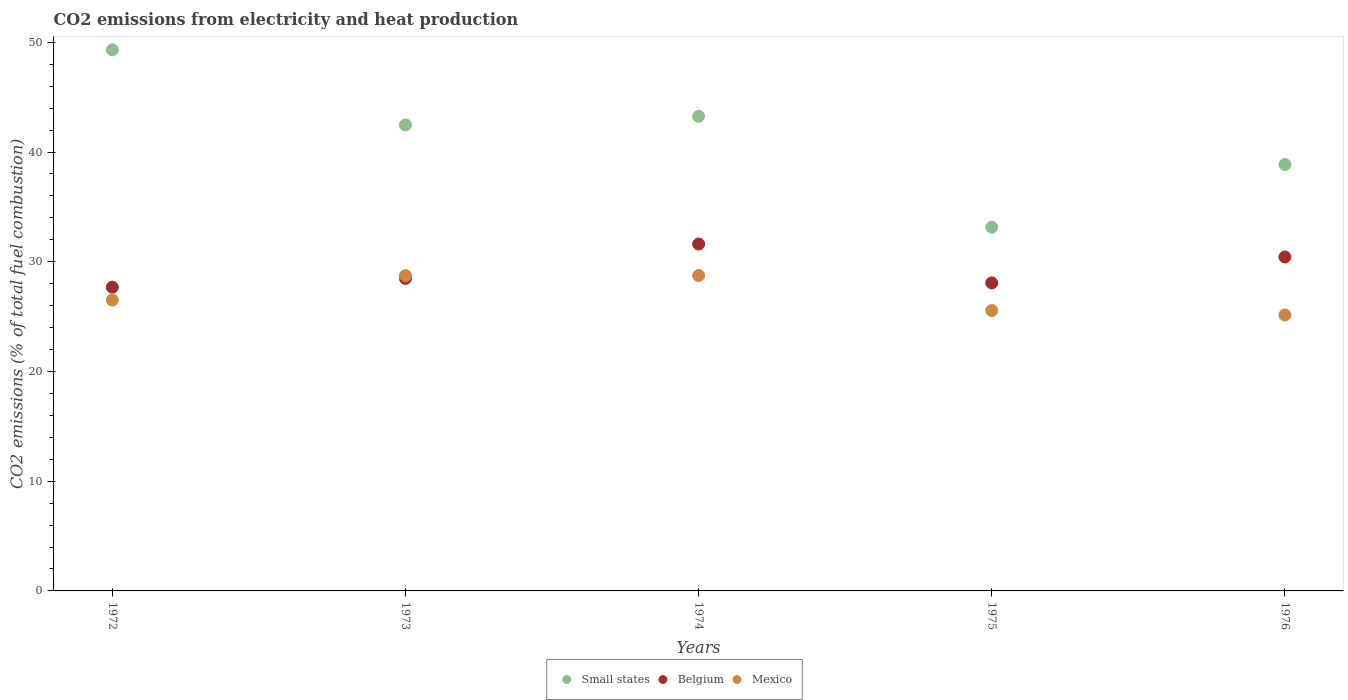What is the amount of CO2 emitted in Mexico in 1972?
Offer a very short reply. 26.51. Across all years, what is the maximum amount of CO2 emitted in Belgium?
Offer a very short reply. 31.62. Across all years, what is the minimum amount of CO2 emitted in Belgium?
Your answer should be compact. 27.68. In which year was the amount of CO2 emitted in Mexico maximum?
Your response must be concise. 1974. What is the total amount of CO2 emitted in Mexico in the graph?
Give a very brief answer. 134.69. What is the difference between the amount of CO2 emitted in Small states in 1972 and that in 1976?
Ensure brevity in your answer.  10.45. What is the difference between the amount of CO2 emitted in Belgium in 1975 and the amount of CO2 emitted in Mexico in 1972?
Provide a short and direct response. 1.56. What is the average amount of CO2 emitted in Belgium per year?
Your response must be concise. 29.26. In the year 1972, what is the difference between the amount of CO2 emitted in Belgium and amount of CO2 emitted in Mexico?
Offer a very short reply. 1.17. What is the ratio of the amount of CO2 emitted in Belgium in 1972 to that in 1975?
Your answer should be very brief. 0.99. What is the difference between the highest and the second highest amount of CO2 emitted in Belgium?
Keep it short and to the point. 1.18. What is the difference between the highest and the lowest amount of CO2 emitted in Mexico?
Offer a terse response. 3.6. Is it the case that in every year, the sum of the amount of CO2 emitted in Small states and amount of CO2 emitted in Belgium  is greater than the amount of CO2 emitted in Mexico?
Your answer should be very brief. Yes. Is the amount of CO2 emitted in Small states strictly greater than the amount of CO2 emitted in Belgium over the years?
Offer a very short reply. Yes. Is the amount of CO2 emitted in Small states strictly less than the amount of CO2 emitted in Mexico over the years?
Give a very brief answer. No. How many dotlines are there?
Make the answer very short. 3. How many years are there in the graph?
Give a very brief answer. 5. Are the values on the major ticks of Y-axis written in scientific E-notation?
Ensure brevity in your answer.  No. Where does the legend appear in the graph?
Give a very brief answer. Bottom center. How many legend labels are there?
Keep it short and to the point. 3. What is the title of the graph?
Offer a terse response. CO2 emissions from electricity and heat production. Does "Poland" appear as one of the legend labels in the graph?
Keep it short and to the point. No. What is the label or title of the Y-axis?
Your response must be concise. CO2 emissions (% of total fuel combustion). What is the CO2 emissions (% of total fuel combustion) in Small states in 1972?
Make the answer very short. 49.31. What is the CO2 emissions (% of total fuel combustion) of Belgium in 1972?
Give a very brief answer. 27.68. What is the CO2 emissions (% of total fuel combustion) in Mexico in 1972?
Provide a succinct answer. 26.51. What is the CO2 emissions (% of total fuel combustion) of Small states in 1973?
Make the answer very short. 42.47. What is the CO2 emissions (% of total fuel combustion) of Belgium in 1973?
Give a very brief answer. 28.48. What is the CO2 emissions (% of total fuel combustion) in Mexico in 1973?
Keep it short and to the point. 28.73. What is the CO2 emissions (% of total fuel combustion) of Small states in 1974?
Your answer should be very brief. 43.26. What is the CO2 emissions (% of total fuel combustion) in Belgium in 1974?
Provide a short and direct response. 31.62. What is the CO2 emissions (% of total fuel combustion) of Mexico in 1974?
Your answer should be very brief. 28.74. What is the CO2 emissions (% of total fuel combustion) in Small states in 1975?
Give a very brief answer. 33.15. What is the CO2 emissions (% of total fuel combustion) of Belgium in 1975?
Your answer should be very brief. 28.07. What is the CO2 emissions (% of total fuel combustion) of Mexico in 1975?
Your answer should be compact. 25.56. What is the CO2 emissions (% of total fuel combustion) of Small states in 1976?
Provide a succinct answer. 38.86. What is the CO2 emissions (% of total fuel combustion) of Belgium in 1976?
Offer a very short reply. 30.44. What is the CO2 emissions (% of total fuel combustion) in Mexico in 1976?
Ensure brevity in your answer.  25.15. Across all years, what is the maximum CO2 emissions (% of total fuel combustion) of Small states?
Your answer should be very brief. 49.31. Across all years, what is the maximum CO2 emissions (% of total fuel combustion) in Belgium?
Ensure brevity in your answer.  31.62. Across all years, what is the maximum CO2 emissions (% of total fuel combustion) in Mexico?
Ensure brevity in your answer.  28.74. Across all years, what is the minimum CO2 emissions (% of total fuel combustion) of Small states?
Your answer should be compact. 33.15. Across all years, what is the minimum CO2 emissions (% of total fuel combustion) in Belgium?
Your answer should be compact. 27.68. Across all years, what is the minimum CO2 emissions (% of total fuel combustion) of Mexico?
Make the answer very short. 25.15. What is the total CO2 emissions (% of total fuel combustion) in Small states in the graph?
Give a very brief answer. 207.05. What is the total CO2 emissions (% of total fuel combustion) of Belgium in the graph?
Make the answer very short. 146.28. What is the total CO2 emissions (% of total fuel combustion) of Mexico in the graph?
Provide a short and direct response. 134.69. What is the difference between the CO2 emissions (% of total fuel combustion) in Small states in 1972 and that in 1973?
Ensure brevity in your answer.  6.84. What is the difference between the CO2 emissions (% of total fuel combustion) of Belgium in 1972 and that in 1973?
Keep it short and to the point. -0.8. What is the difference between the CO2 emissions (% of total fuel combustion) of Mexico in 1972 and that in 1973?
Offer a very short reply. -2.22. What is the difference between the CO2 emissions (% of total fuel combustion) of Small states in 1972 and that in 1974?
Offer a very short reply. 6.06. What is the difference between the CO2 emissions (% of total fuel combustion) in Belgium in 1972 and that in 1974?
Your response must be concise. -3.93. What is the difference between the CO2 emissions (% of total fuel combustion) of Mexico in 1972 and that in 1974?
Provide a succinct answer. -2.24. What is the difference between the CO2 emissions (% of total fuel combustion) in Small states in 1972 and that in 1975?
Give a very brief answer. 16.16. What is the difference between the CO2 emissions (% of total fuel combustion) in Belgium in 1972 and that in 1975?
Ensure brevity in your answer.  -0.39. What is the difference between the CO2 emissions (% of total fuel combustion) in Mexico in 1972 and that in 1975?
Provide a succinct answer. 0.95. What is the difference between the CO2 emissions (% of total fuel combustion) of Small states in 1972 and that in 1976?
Make the answer very short. 10.45. What is the difference between the CO2 emissions (% of total fuel combustion) of Belgium in 1972 and that in 1976?
Your answer should be compact. -2.76. What is the difference between the CO2 emissions (% of total fuel combustion) of Mexico in 1972 and that in 1976?
Your answer should be very brief. 1.36. What is the difference between the CO2 emissions (% of total fuel combustion) in Small states in 1973 and that in 1974?
Give a very brief answer. -0.79. What is the difference between the CO2 emissions (% of total fuel combustion) of Belgium in 1973 and that in 1974?
Provide a succinct answer. -3.14. What is the difference between the CO2 emissions (% of total fuel combustion) in Mexico in 1973 and that in 1974?
Give a very brief answer. -0.01. What is the difference between the CO2 emissions (% of total fuel combustion) in Small states in 1973 and that in 1975?
Make the answer very short. 9.32. What is the difference between the CO2 emissions (% of total fuel combustion) of Belgium in 1973 and that in 1975?
Your answer should be compact. 0.41. What is the difference between the CO2 emissions (% of total fuel combustion) in Mexico in 1973 and that in 1975?
Give a very brief answer. 3.18. What is the difference between the CO2 emissions (% of total fuel combustion) in Small states in 1973 and that in 1976?
Offer a terse response. 3.61. What is the difference between the CO2 emissions (% of total fuel combustion) in Belgium in 1973 and that in 1976?
Offer a very short reply. -1.96. What is the difference between the CO2 emissions (% of total fuel combustion) of Mexico in 1973 and that in 1976?
Ensure brevity in your answer.  3.59. What is the difference between the CO2 emissions (% of total fuel combustion) in Small states in 1974 and that in 1975?
Provide a short and direct response. 10.11. What is the difference between the CO2 emissions (% of total fuel combustion) in Belgium in 1974 and that in 1975?
Your answer should be compact. 3.54. What is the difference between the CO2 emissions (% of total fuel combustion) in Mexico in 1974 and that in 1975?
Provide a short and direct response. 3.19. What is the difference between the CO2 emissions (% of total fuel combustion) in Small states in 1974 and that in 1976?
Provide a short and direct response. 4.39. What is the difference between the CO2 emissions (% of total fuel combustion) in Belgium in 1974 and that in 1976?
Your answer should be very brief. 1.18. What is the difference between the CO2 emissions (% of total fuel combustion) of Mexico in 1974 and that in 1976?
Offer a terse response. 3.6. What is the difference between the CO2 emissions (% of total fuel combustion) of Small states in 1975 and that in 1976?
Provide a short and direct response. -5.71. What is the difference between the CO2 emissions (% of total fuel combustion) of Belgium in 1975 and that in 1976?
Make the answer very short. -2.36. What is the difference between the CO2 emissions (% of total fuel combustion) of Mexico in 1975 and that in 1976?
Your answer should be compact. 0.41. What is the difference between the CO2 emissions (% of total fuel combustion) in Small states in 1972 and the CO2 emissions (% of total fuel combustion) in Belgium in 1973?
Your answer should be compact. 20.83. What is the difference between the CO2 emissions (% of total fuel combustion) of Small states in 1972 and the CO2 emissions (% of total fuel combustion) of Mexico in 1973?
Your response must be concise. 20.58. What is the difference between the CO2 emissions (% of total fuel combustion) of Belgium in 1972 and the CO2 emissions (% of total fuel combustion) of Mexico in 1973?
Ensure brevity in your answer.  -1.05. What is the difference between the CO2 emissions (% of total fuel combustion) of Small states in 1972 and the CO2 emissions (% of total fuel combustion) of Belgium in 1974?
Keep it short and to the point. 17.7. What is the difference between the CO2 emissions (% of total fuel combustion) in Small states in 1972 and the CO2 emissions (% of total fuel combustion) in Mexico in 1974?
Offer a terse response. 20.57. What is the difference between the CO2 emissions (% of total fuel combustion) in Belgium in 1972 and the CO2 emissions (% of total fuel combustion) in Mexico in 1974?
Your answer should be compact. -1.06. What is the difference between the CO2 emissions (% of total fuel combustion) in Small states in 1972 and the CO2 emissions (% of total fuel combustion) in Belgium in 1975?
Provide a short and direct response. 21.24. What is the difference between the CO2 emissions (% of total fuel combustion) of Small states in 1972 and the CO2 emissions (% of total fuel combustion) of Mexico in 1975?
Keep it short and to the point. 23.76. What is the difference between the CO2 emissions (% of total fuel combustion) in Belgium in 1972 and the CO2 emissions (% of total fuel combustion) in Mexico in 1975?
Your response must be concise. 2.12. What is the difference between the CO2 emissions (% of total fuel combustion) in Small states in 1972 and the CO2 emissions (% of total fuel combustion) in Belgium in 1976?
Provide a succinct answer. 18.88. What is the difference between the CO2 emissions (% of total fuel combustion) in Small states in 1972 and the CO2 emissions (% of total fuel combustion) in Mexico in 1976?
Your answer should be compact. 24.16. What is the difference between the CO2 emissions (% of total fuel combustion) of Belgium in 1972 and the CO2 emissions (% of total fuel combustion) of Mexico in 1976?
Offer a very short reply. 2.53. What is the difference between the CO2 emissions (% of total fuel combustion) in Small states in 1973 and the CO2 emissions (% of total fuel combustion) in Belgium in 1974?
Your response must be concise. 10.85. What is the difference between the CO2 emissions (% of total fuel combustion) in Small states in 1973 and the CO2 emissions (% of total fuel combustion) in Mexico in 1974?
Your response must be concise. 13.72. What is the difference between the CO2 emissions (% of total fuel combustion) in Belgium in 1973 and the CO2 emissions (% of total fuel combustion) in Mexico in 1974?
Provide a succinct answer. -0.27. What is the difference between the CO2 emissions (% of total fuel combustion) of Small states in 1973 and the CO2 emissions (% of total fuel combustion) of Belgium in 1975?
Keep it short and to the point. 14.4. What is the difference between the CO2 emissions (% of total fuel combustion) in Small states in 1973 and the CO2 emissions (% of total fuel combustion) in Mexico in 1975?
Provide a short and direct response. 16.91. What is the difference between the CO2 emissions (% of total fuel combustion) of Belgium in 1973 and the CO2 emissions (% of total fuel combustion) of Mexico in 1975?
Ensure brevity in your answer.  2.92. What is the difference between the CO2 emissions (% of total fuel combustion) in Small states in 1973 and the CO2 emissions (% of total fuel combustion) in Belgium in 1976?
Keep it short and to the point. 12.03. What is the difference between the CO2 emissions (% of total fuel combustion) of Small states in 1973 and the CO2 emissions (% of total fuel combustion) of Mexico in 1976?
Keep it short and to the point. 17.32. What is the difference between the CO2 emissions (% of total fuel combustion) of Belgium in 1973 and the CO2 emissions (% of total fuel combustion) of Mexico in 1976?
Provide a short and direct response. 3.33. What is the difference between the CO2 emissions (% of total fuel combustion) in Small states in 1974 and the CO2 emissions (% of total fuel combustion) in Belgium in 1975?
Give a very brief answer. 15.18. What is the difference between the CO2 emissions (% of total fuel combustion) in Small states in 1974 and the CO2 emissions (% of total fuel combustion) in Mexico in 1975?
Ensure brevity in your answer.  17.7. What is the difference between the CO2 emissions (% of total fuel combustion) of Belgium in 1974 and the CO2 emissions (% of total fuel combustion) of Mexico in 1975?
Your response must be concise. 6.06. What is the difference between the CO2 emissions (% of total fuel combustion) in Small states in 1974 and the CO2 emissions (% of total fuel combustion) in Belgium in 1976?
Your answer should be very brief. 12.82. What is the difference between the CO2 emissions (% of total fuel combustion) of Small states in 1974 and the CO2 emissions (% of total fuel combustion) of Mexico in 1976?
Your answer should be very brief. 18.11. What is the difference between the CO2 emissions (% of total fuel combustion) in Belgium in 1974 and the CO2 emissions (% of total fuel combustion) in Mexico in 1976?
Give a very brief answer. 6.47. What is the difference between the CO2 emissions (% of total fuel combustion) in Small states in 1975 and the CO2 emissions (% of total fuel combustion) in Belgium in 1976?
Keep it short and to the point. 2.71. What is the difference between the CO2 emissions (% of total fuel combustion) in Small states in 1975 and the CO2 emissions (% of total fuel combustion) in Mexico in 1976?
Ensure brevity in your answer.  8. What is the difference between the CO2 emissions (% of total fuel combustion) of Belgium in 1975 and the CO2 emissions (% of total fuel combustion) of Mexico in 1976?
Ensure brevity in your answer.  2.92. What is the average CO2 emissions (% of total fuel combustion) of Small states per year?
Provide a succinct answer. 41.41. What is the average CO2 emissions (% of total fuel combustion) in Belgium per year?
Give a very brief answer. 29.26. What is the average CO2 emissions (% of total fuel combustion) of Mexico per year?
Offer a very short reply. 26.94. In the year 1972, what is the difference between the CO2 emissions (% of total fuel combustion) in Small states and CO2 emissions (% of total fuel combustion) in Belgium?
Make the answer very short. 21.63. In the year 1972, what is the difference between the CO2 emissions (% of total fuel combustion) of Small states and CO2 emissions (% of total fuel combustion) of Mexico?
Provide a short and direct response. 22.8. In the year 1972, what is the difference between the CO2 emissions (% of total fuel combustion) of Belgium and CO2 emissions (% of total fuel combustion) of Mexico?
Your answer should be compact. 1.17. In the year 1973, what is the difference between the CO2 emissions (% of total fuel combustion) in Small states and CO2 emissions (% of total fuel combustion) in Belgium?
Your answer should be very brief. 13.99. In the year 1973, what is the difference between the CO2 emissions (% of total fuel combustion) of Small states and CO2 emissions (% of total fuel combustion) of Mexico?
Your response must be concise. 13.74. In the year 1973, what is the difference between the CO2 emissions (% of total fuel combustion) of Belgium and CO2 emissions (% of total fuel combustion) of Mexico?
Your answer should be very brief. -0.26. In the year 1974, what is the difference between the CO2 emissions (% of total fuel combustion) in Small states and CO2 emissions (% of total fuel combustion) in Belgium?
Offer a terse response. 11.64. In the year 1974, what is the difference between the CO2 emissions (% of total fuel combustion) in Small states and CO2 emissions (% of total fuel combustion) in Mexico?
Provide a short and direct response. 14.51. In the year 1974, what is the difference between the CO2 emissions (% of total fuel combustion) in Belgium and CO2 emissions (% of total fuel combustion) in Mexico?
Your answer should be compact. 2.87. In the year 1975, what is the difference between the CO2 emissions (% of total fuel combustion) of Small states and CO2 emissions (% of total fuel combustion) of Belgium?
Ensure brevity in your answer.  5.08. In the year 1975, what is the difference between the CO2 emissions (% of total fuel combustion) of Small states and CO2 emissions (% of total fuel combustion) of Mexico?
Your answer should be very brief. 7.59. In the year 1975, what is the difference between the CO2 emissions (% of total fuel combustion) in Belgium and CO2 emissions (% of total fuel combustion) in Mexico?
Provide a short and direct response. 2.52. In the year 1976, what is the difference between the CO2 emissions (% of total fuel combustion) in Small states and CO2 emissions (% of total fuel combustion) in Belgium?
Offer a terse response. 8.43. In the year 1976, what is the difference between the CO2 emissions (% of total fuel combustion) of Small states and CO2 emissions (% of total fuel combustion) of Mexico?
Make the answer very short. 13.71. In the year 1976, what is the difference between the CO2 emissions (% of total fuel combustion) in Belgium and CO2 emissions (% of total fuel combustion) in Mexico?
Give a very brief answer. 5.29. What is the ratio of the CO2 emissions (% of total fuel combustion) in Small states in 1972 to that in 1973?
Offer a terse response. 1.16. What is the ratio of the CO2 emissions (% of total fuel combustion) in Belgium in 1972 to that in 1973?
Ensure brevity in your answer.  0.97. What is the ratio of the CO2 emissions (% of total fuel combustion) in Mexico in 1972 to that in 1973?
Your answer should be very brief. 0.92. What is the ratio of the CO2 emissions (% of total fuel combustion) of Small states in 1972 to that in 1974?
Provide a short and direct response. 1.14. What is the ratio of the CO2 emissions (% of total fuel combustion) of Belgium in 1972 to that in 1974?
Offer a very short reply. 0.88. What is the ratio of the CO2 emissions (% of total fuel combustion) of Mexico in 1972 to that in 1974?
Your answer should be compact. 0.92. What is the ratio of the CO2 emissions (% of total fuel combustion) of Small states in 1972 to that in 1975?
Ensure brevity in your answer.  1.49. What is the ratio of the CO2 emissions (% of total fuel combustion) in Belgium in 1972 to that in 1975?
Keep it short and to the point. 0.99. What is the ratio of the CO2 emissions (% of total fuel combustion) of Mexico in 1972 to that in 1975?
Provide a short and direct response. 1.04. What is the ratio of the CO2 emissions (% of total fuel combustion) of Small states in 1972 to that in 1976?
Offer a terse response. 1.27. What is the ratio of the CO2 emissions (% of total fuel combustion) in Belgium in 1972 to that in 1976?
Ensure brevity in your answer.  0.91. What is the ratio of the CO2 emissions (% of total fuel combustion) of Mexico in 1972 to that in 1976?
Provide a succinct answer. 1.05. What is the ratio of the CO2 emissions (% of total fuel combustion) in Small states in 1973 to that in 1974?
Keep it short and to the point. 0.98. What is the ratio of the CO2 emissions (% of total fuel combustion) in Belgium in 1973 to that in 1974?
Provide a succinct answer. 0.9. What is the ratio of the CO2 emissions (% of total fuel combustion) of Mexico in 1973 to that in 1974?
Your response must be concise. 1. What is the ratio of the CO2 emissions (% of total fuel combustion) in Small states in 1973 to that in 1975?
Your answer should be very brief. 1.28. What is the ratio of the CO2 emissions (% of total fuel combustion) of Belgium in 1973 to that in 1975?
Give a very brief answer. 1.01. What is the ratio of the CO2 emissions (% of total fuel combustion) in Mexico in 1973 to that in 1975?
Your answer should be compact. 1.12. What is the ratio of the CO2 emissions (% of total fuel combustion) of Small states in 1973 to that in 1976?
Offer a terse response. 1.09. What is the ratio of the CO2 emissions (% of total fuel combustion) of Belgium in 1973 to that in 1976?
Offer a very short reply. 0.94. What is the ratio of the CO2 emissions (% of total fuel combustion) in Mexico in 1973 to that in 1976?
Provide a short and direct response. 1.14. What is the ratio of the CO2 emissions (% of total fuel combustion) of Small states in 1974 to that in 1975?
Ensure brevity in your answer.  1.3. What is the ratio of the CO2 emissions (% of total fuel combustion) in Belgium in 1974 to that in 1975?
Keep it short and to the point. 1.13. What is the ratio of the CO2 emissions (% of total fuel combustion) of Mexico in 1974 to that in 1975?
Your response must be concise. 1.12. What is the ratio of the CO2 emissions (% of total fuel combustion) in Small states in 1974 to that in 1976?
Keep it short and to the point. 1.11. What is the ratio of the CO2 emissions (% of total fuel combustion) of Belgium in 1974 to that in 1976?
Your answer should be compact. 1.04. What is the ratio of the CO2 emissions (% of total fuel combustion) in Mexico in 1974 to that in 1976?
Keep it short and to the point. 1.14. What is the ratio of the CO2 emissions (% of total fuel combustion) of Small states in 1975 to that in 1976?
Provide a short and direct response. 0.85. What is the ratio of the CO2 emissions (% of total fuel combustion) in Belgium in 1975 to that in 1976?
Ensure brevity in your answer.  0.92. What is the ratio of the CO2 emissions (% of total fuel combustion) in Mexico in 1975 to that in 1976?
Offer a very short reply. 1.02. What is the difference between the highest and the second highest CO2 emissions (% of total fuel combustion) of Small states?
Keep it short and to the point. 6.06. What is the difference between the highest and the second highest CO2 emissions (% of total fuel combustion) in Belgium?
Your response must be concise. 1.18. What is the difference between the highest and the second highest CO2 emissions (% of total fuel combustion) of Mexico?
Offer a terse response. 0.01. What is the difference between the highest and the lowest CO2 emissions (% of total fuel combustion) of Small states?
Offer a very short reply. 16.16. What is the difference between the highest and the lowest CO2 emissions (% of total fuel combustion) of Belgium?
Your answer should be compact. 3.93. What is the difference between the highest and the lowest CO2 emissions (% of total fuel combustion) in Mexico?
Ensure brevity in your answer.  3.6. 